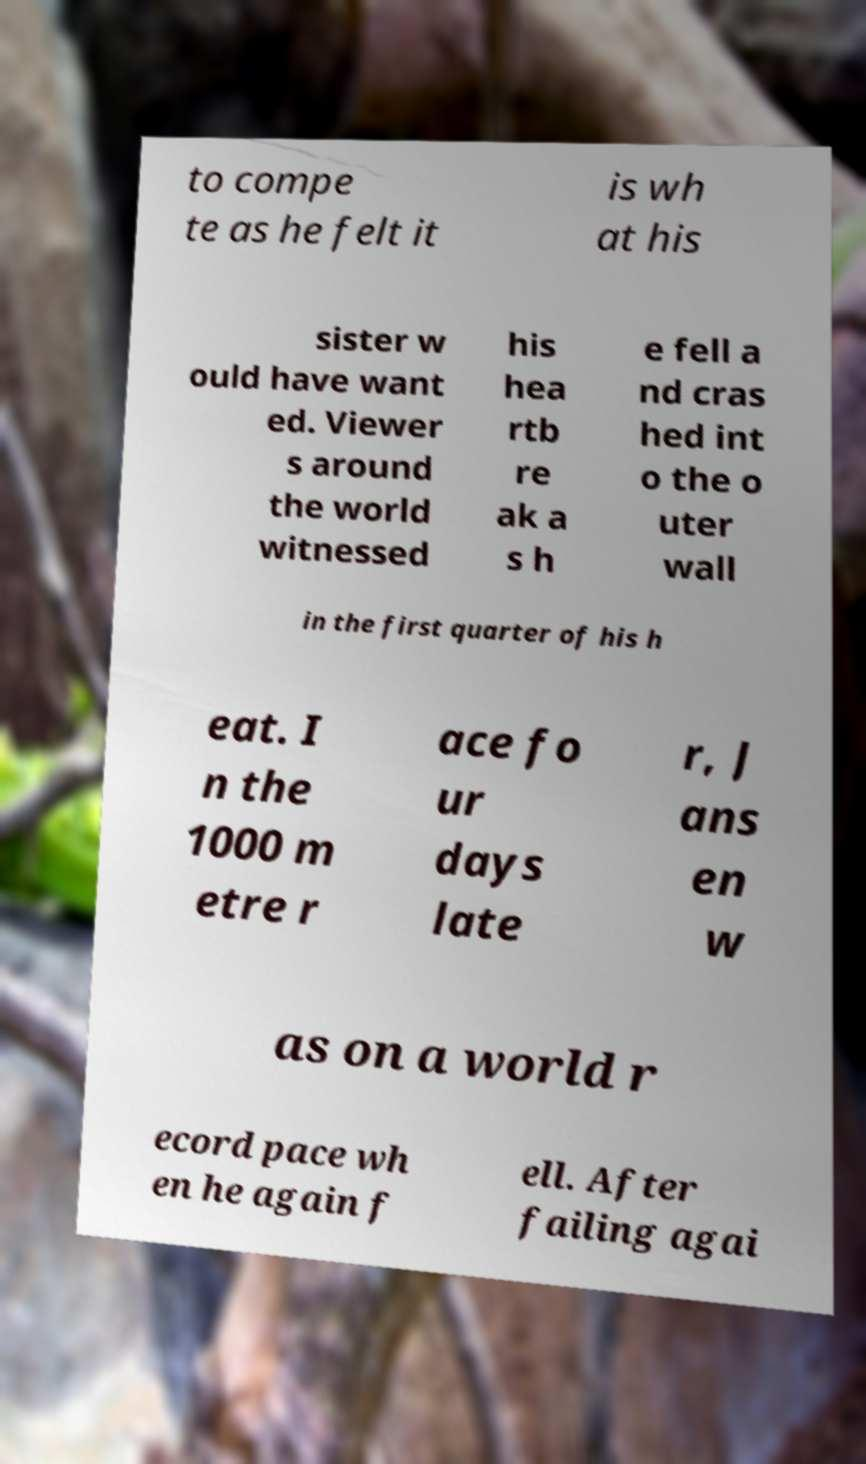What messages or text are displayed in this image? I need them in a readable, typed format. to compe te as he felt it is wh at his sister w ould have want ed. Viewer s around the world witnessed his hea rtb re ak a s h e fell a nd cras hed int o the o uter wall in the first quarter of his h eat. I n the 1000 m etre r ace fo ur days late r, J ans en w as on a world r ecord pace wh en he again f ell. After failing agai 